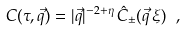Convert formula to latex. <formula><loc_0><loc_0><loc_500><loc_500>C ( \tau , \vec { q } ) = | \vec { q } | ^ { - 2 + \eta } \, { \hat { C } } _ { \pm } ( \vec { q } \, \xi ) \ ,</formula> 